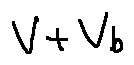Convert formula to latex. <formula><loc_0><loc_0><loc_500><loc_500>V + V _ { b }</formula> 